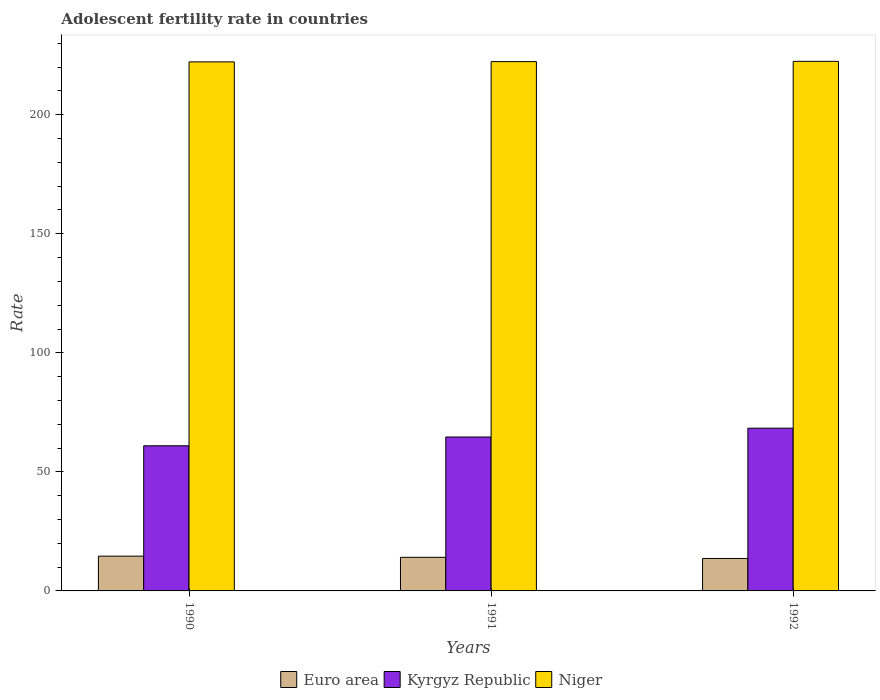How many groups of bars are there?
Your answer should be very brief. 3. Are the number of bars on each tick of the X-axis equal?
Offer a terse response. Yes. How many bars are there on the 1st tick from the left?
Provide a short and direct response. 3. How many bars are there on the 1st tick from the right?
Offer a very short reply. 3. In how many cases, is the number of bars for a given year not equal to the number of legend labels?
Ensure brevity in your answer.  0. What is the adolescent fertility rate in Euro area in 1990?
Your answer should be very brief. 14.6. Across all years, what is the maximum adolescent fertility rate in Kyrgyz Republic?
Ensure brevity in your answer.  68.35. Across all years, what is the minimum adolescent fertility rate in Niger?
Your response must be concise. 222.21. In which year was the adolescent fertility rate in Niger minimum?
Keep it short and to the point. 1990. What is the total adolescent fertility rate in Kyrgyz Republic in the graph?
Offer a terse response. 193.96. What is the difference between the adolescent fertility rate in Kyrgyz Republic in 1990 and that in 1991?
Your response must be concise. -3.69. What is the difference between the adolescent fertility rate in Kyrgyz Republic in 1992 and the adolescent fertility rate in Niger in 1991?
Offer a very short reply. -153.98. What is the average adolescent fertility rate in Euro area per year?
Give a very brief answer. 14.12. In the year 1991, what is the difference between the adolescent fertility rate in Euro area and adolescent fertility rate in Niger?
Provide a short and direct response. -208.21. In how many years, is the adolescent fertility rate in Niger greater than 130?
Keep it short and to the point. 3. What is the ratio of the adolescent fertility rate in Kyrgyz Republic in 1990 to that in 1991?
Make the answer very short. 0.94. Is the difference between the adolescent fertility rate in Euro area in 1990 and 1991 greater than the difference between the adolescent fertility rate in Niger in 1990 and 1991?
Offer a very short reply. Yes. What is the difference between the highest and the second highest adolescent fertility rate in Kyrgyz Republic?
Provide a succinct answer. 3.69. What is the difference between the highest and the lowest adolescent fertility rate in Euro area?
Ensure brevity in your answer.  0.98. Is the sum of the adolescent fertility rate in Euro area in 1991 and 1992 greater than the maximum adolescent fertility rate in Kyrgyz Republic across all years?
Make the answer very short. No. What does the 3rd bar from the left in 1992 represents?
Keep it short and to the point. Niger. What does the 3rd bar from the right in 1991 represents?
Keep it short and to the point. Euro area. How many bars are there?
Provide a short and direct response. 9. Are all the bars in the graph horizontal?
Your answer should be very brief. No. What is the difference between two consecutive major ticks on the Y-axis?
Your response must be concise. 50. Does the graph contain grids?
Offer a very short reply. No. How many legend labels are there?
Offer a terse response. 3. What is the title of the graph?
Your answer should be compact. Adolescent fertility rate in countries. What is the label or title of the X-axis?
Offer a terse response. Years. What is the label or title of the Y-axis?
Offer a very short reply. Rate. What is the Rate in Euro area in 1990?
Ensure brevity in your answer.  14.6. What is the Rate in Kyrgyz Republic in 1990?
Make the answer very short. 60.96. What is the Rate in Niger in 1990?
Make the answer very short. 222.21. What is the Rate in Euro area in 1991?
Offer a terse response. 14.12. What is the Rate of Kyrgyz Republic in 1991?
Offer a terse response. 64.65. What is the Rate of Niger in 1991?
Make the answer very short. 222.32. What is the Rate in Euro area in 1992?
Make the answer very short. 13.63. What is the Rate of Kyrgyz Republic in 1992?
Give a very brief answer. 68.35. What is the Rate in Niger in 1992?
Offer a very short reply. 222.44. Across all years, what is the maximum Rate in Euro area?
Provide a short and direct response. 14.6. Across all years, what is the maximum Rate in Kyrgyz Republic?
Offer a terse response. 68.35. Across all years, what is the maximum Rate of Niger?
Provide a short and direct response. 222.44. Across all years, what is the minimum Rate in Euro area?
Offer a very short reply. 13.63. Across all years, what is the minimum Rate of Kyrgyz Republic?
Provide a short and direct response. 60.96. Across all years, what is the minimum Rate in Niger?
Offer a terse response. 222.21. What is the total Rate in Euro area in the graph?
Offer a very short reply. 42.35. What is the total Rate of Kyrgyz Republic in the graph?
Offer a terse response. 193.96. What is the total Rate in Niger in the graph?
Offer a very short reply. 666.97. What is the difference between the Rate of Euro area in 1990 and that in 1991?
Your answer should be very brief. 0.49. What is the difference between the Rate of Kyrgyz Republic in 1990 and that in 1991?
Provide a short and direct response. -3.69. What is the difference between the Rate of Niger in 1990 and that in 1991?
Provide a succinct answer. -0.11. What is the difference between the Rate in Euro area in 1990 and that in 1992?
Your response must be concise. 0.98. What is the difference between the Rate of Kyrgyz Republic in 1990 and that in 1992?
Provide a short and direct response. -7.39. What is the difference between the Rate of Niger in 1990 and that in 1992?
Make the answer very short. -0.22. What is the difference between the Rate in Euro area in 1991 and that in 1992?
Offer a terse response. 0.49. What is the difference between the Rate in Kyrgyz Republic in 1991 and that in 1992?
Give a very brief answer. -3.69. What is the difference between the Rate in Niger in 1991 and that in 1992?
Keep it short and to the point. -0.11. What is the difference between the Rate in Euro area in 1990 and the Rate in Kyrgyz Republic in 1991?
Make the answer very short. -50.05. What is the difference between the Rate in Euro area in 1990 and the Rate in Niger in 1991?
Keep it short and to the point. -207.72. What is the difference between the Rate in Kyrgyz Republic in 1990 and the Rate in Niger in 1991?
Offer a very short reply. -161.36. What is the difference between the Rate of Euro area in 1990 and the Rate of Kyrgyz Republic in 1992?
Your answer should be very brief. -53.74. What is the difference between the Rate of Euro area in 1990 and the Rate of Niger in 1992?
Give a very brief answer. -207.83. What is the difference between the Rate in Kyrgyz Republic in 1990 and the Rate in Niger in 1992?
Your response must be concise. -161.47. What is the difference between the Rate of Euro area in 1991 and the Rate of Kyrgyz Republic in 1992?
Ensure brevity in your answer.  -54.23. What is the difference between the Rate of Euro area in 1991 and the Rate of Niger in 1992?
Make the answer very short. -208.32. What is the difference between the Rate in Kyrgyz Republic in 1991 and the Rate in Niger in 1992?
Give a very brief answer. -157.78. What is the average Rate of Euro area per year?
Your answer should be very brief. 14.12. What is the average Rate in Kyrgyz Republic per year?
Your response must be concise. 64.65. What is the average Rate of Niger per year?
Ensure brevity in your answer.  222.32. In the year 1990, what is the difference between the Rate of Euro area and Rate of Kyrgyz Republic?
Ensure brevity in your answer.  -46.36. In the year 1990, what is the difference between the Rate of Euro area and Rate of Niger?
Keep it short and to the point. -207.61. In the year 1990, what is the difference between the Rate in Kyrgyz Republic and Rate in Niger?
Keep it short and to the point. -161.25. In the year 1991, what is the difference between the Rate in Euro area and Rate in Kyrgyz Republic?
Ensure brevity in your answer.  -50.54. In the year 1991, what is the difference between the Rate in Euro area and Rate in Niger?
Provide a succinct answer. -208.21. In the year 1991, what is the difference between the Rate of Kyrgyz Republic and Rate of Niger?
Offer a terse response. -157.67. In the year 1992, what is the difference between the Rate in Euro area and Rate in Kyrgyz Republic?
Offer a very short reply. -54.72. In the year 1992, what is the difference between the Rate of Euro area and Rate of Niger?
Ensure brevity in your answer.  -208.81. In the year 1992, what is the difference between the Rate of Kyrgyz Republic and Rate of Niger?
Your response must be concise. -154.09. What is the ratio of the Rate of Euro area in 1990 to that in 1991?
Offer a very short reply. 1.03. What is the ratio of the Rate of Kyrgyz Republic in 1990 to that in 1991?
Make the answer very short. 0.94. What is the ratio of the Rate of Euro area in 1990 to that in 1992?
Offer a very short reply. 1.07. What is the ratio of the Rate in Kyrgyz Republic in 1990 to that in 1992?
Your answer should be very brief. 0.89. What is the ratio of the Rate in Euro area in 1991 to that in 1992?
Offer a terse response. 1.04. What is the ratio of the Rate of Kyrgyz Republic in 1991 to that in 1992?
Offer a terse response. 0.95. What is the difference between the highest and the second highest Rate in Euro area?
Offer a very short reply. 0.49. What is the difference between the highest and the second highest Rate of Kyrgyz Republic?
Your response must be concise. 3.69. What is the difference between the highest and the second highest Rate in Niger?
Your answer should be compact. 0.11. What is the difference between the highest and the lowest Rate of Euro area?
Your answer should be very brief. 0.98. What is the difference between the highest and the lowest Rate of Kyrgyz Republic?
Your answer should be compact. 7.39. What is the difference between the highest and the lowest Rate in Niger?
Your answer should be very brief. 0.22. 